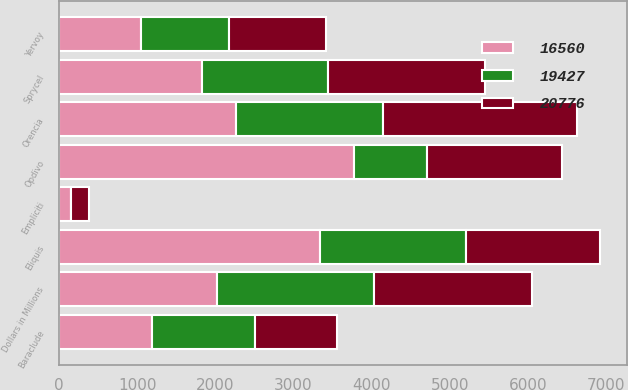Convert chart to OTSL. <chart><loc_0><loc_0><loc_500><loc_500><stacked_bar_chart><ecel><fcel>Dollars in Millions<fcel>Opdivo<fcel>Eliquis<fcel>Orencia<fcel>Sprycel<fcel>Yervoy<fcel>Empliciti<fcel>Baraclude<nl><fcel>20776<fcel>2017<fcel>1722<fcel>1722<fcel>2479<fcel>2005<fcel>1244<fcel>231<fcel>1052<nl><fcel>16560<fcel>2016<fcel>3774<fcel>3343<fcel>2265<fcel>1824<fcel>1053<fcel>150<fcel>1192<nl><fcel>19427<fcel>2015<fcel>942<fcel>1860<fcel>1885<fcel>1620<fcel>1126<fcel>3<fcel>1312<nl></chart> 